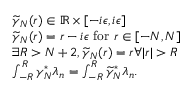<formula> <loc_0><loc_0><loc_500><loc_500>\begin{array} { r l } & { \widetilde { \gamma } _ { N } ( r ) \in \mathbb { R } \times [ - i \epsilon , i \epsilon ] } \\ & { \widetilde { \gamma } _ { N } ( r ) = r - i \epsilon f o r r \in [ - N , N ] } \\ & { \exists R > N + 2 , \widetilde { \gamma } _ { N } ( r ) = r \forall | r | > R } \\ & { \int _ { - R } ^ { R } \gamma _ { N } ^ { * } \lambda _ { n } = \int _ { - R } ^ { R } \widetilde { \gamma } _ { N } ^ { * } \lambda _ { n } . } \end{array}</formula> 